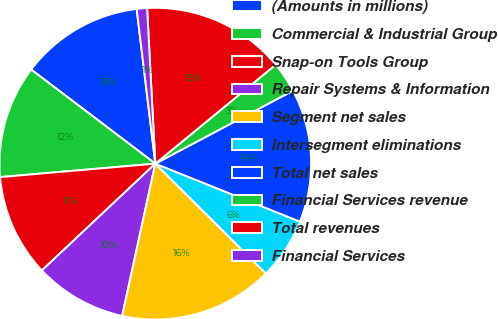<chart> <loc_0><loc_0><loc_500><loc_500><pie_chart><fcel>(Amounts in millions)<fcel>Commercial & Industrial Group<fcel>Snap-on Tools Group<fcel>Repair Systems & Information<fcel>Segment net sales<fcel>Intersegment eliminations<fcel>Total net sales<fcel>Financial Services revenue<fcel>Total revenues<fcel>Financial Services<nl><fcel>12.77%<fcel>11.7%<fcel>10.64%<fcel>9.57%<fcel>15.96%<fcel>6.38%<fcel>13.83%<fcel>3.19%<fcel>14.89%<fcel>1.07%<nl></chart> 